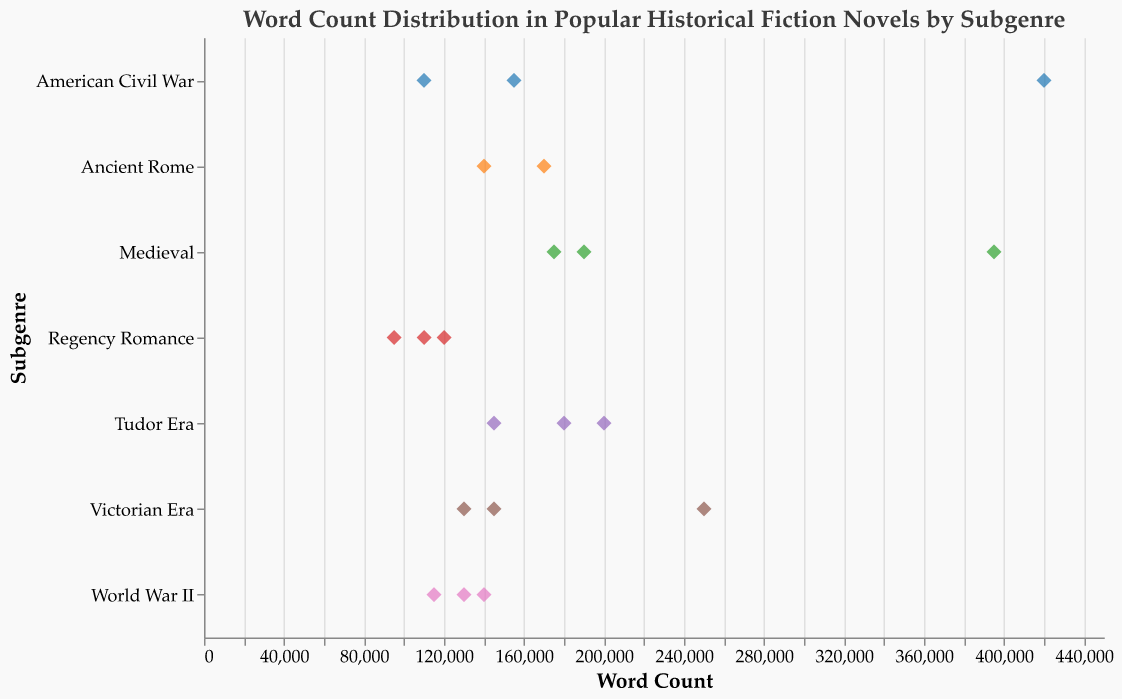What is the title of the figure? The title is displayed at the top of the figure, stating the overall subject of the plot. It reads "Word Count Distribution in Popular Historical Fiction Novels by Subgenre".
Answer: Word Count Distribution in Popular Historical Fiction Novels by Subgenre How many subgenres are there in the plot? The subgenres are listed along the y-axis of the strip plot. There are 7 unique subgenres present: Regency Romance, Tudor Era, World War II, Ancient Rome, American Civil War, Medieval, and Victorian Era.
Answer: 7 Which subgenre has the novel with the highest word count, and what is the title of that novel? The x-axis represents word count, and the subgenre with the farthest point to the right has the highest word count. The American Civil War subgenre has the highest word count with "Gone with the Wind", which has 420,000 words.
Answer: American Civil War, Gone with the Wind Which novel in the Medieval subgenre has the most words? The subgenre "Medieval" along the y-axis lists three novels. Among these, "Pillars of the Earth" is plotted furthest to the right, indicating the highest word count of 395,000 words.
Answer: Pillars of the Earth Compare the average word count of novels in the World War II and Ancient Rome subgenres. Which subgenre has a higher average word count? To find the average word count, sum the word counts of novels within each subgenre and divide by the number of novels. World War II has (130,000 + 140,000 + 115,000) / 3 = 128,333 words on average. Ancient Rome has (140,000 + 170,000) / 2 = 155,000 words on average. Ancient Rome has a higher average word count.
Answer: Ancient Rome Which subgenre contains the novel with the fewest words, and what is the title? The x-axis represents word count, and the novel plotted closest to the left across all subgenres indicates the fewest words. "Bridgerton: The Duke and I" in the Regency Romance subgenre has the fewest words at 95,000.
Answer: Regency Romance, Bridgerton: The Duke and I Are there any subgenres where all novels have word counts higher than 100,000? Check each subgenre to ensure all novels have word counts higher than 100,000 by visually inspecting the plot. Subgenres that meet this criterion are Ancient Rome, American Civil War, Medieval, Tudor Era, and Victorian Era.
Answer: Yes What is the range of word counts in the Victorian Era subgenre? Identify the minimum and maximum word counts within the Victorian Era subgenre by locating the leftmost and rightmost points. The range is found by subtracting the minimum word count from the maximum. The range is from 130,000 (Fingersmith) to 250,000 (The Crimson Petal and the White).
Answer: 130,000 to 250,000 Find the difference in word count between "The Crimson Petal and the White" and "Fingersmith" in the Victorian Era subgenre. Subtract the word count of "Fingersmith" from that of "The Crimson Petal and the White". 250,000 - 130,000 = 120,000 words.
Answer: 120,000 